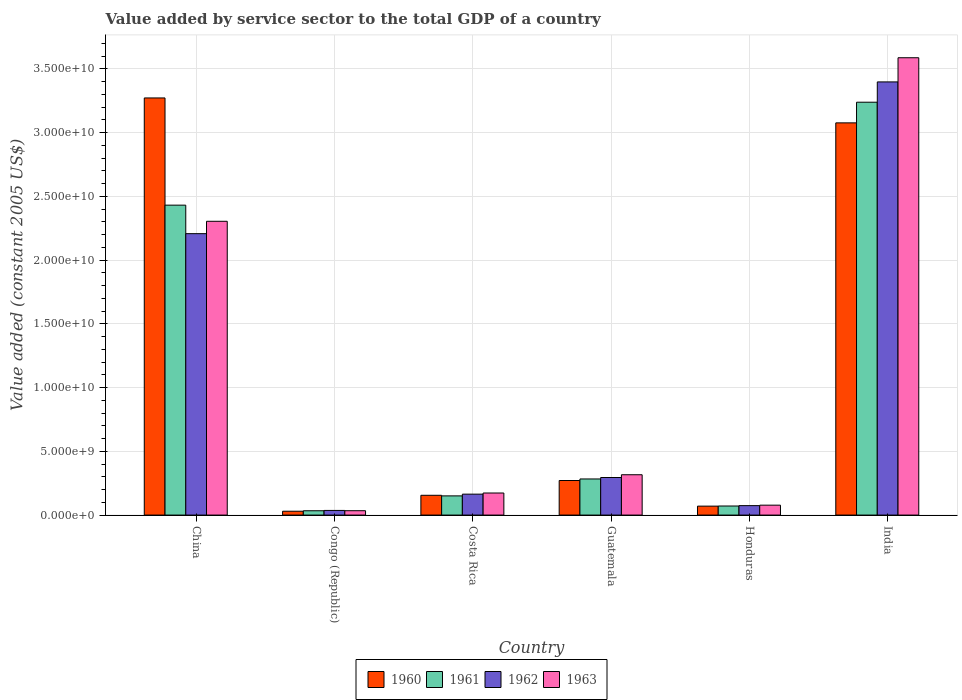How many different coloured bars are there?
Keep it short and to the point. 4. How many groups of bars are there?
Ensure brevity in your answer.  6. Are the number of bars per tick equal to the number of legend labels?
Offer a terse response. Yes. Are the number of bars on each tick of the X-axis equal?
Offer a terse response. Yes. How many bars are there on the 6th tick from the left?
Provide a short and direct response. 4. What is the label of the 5th group of bars from the left?
Give a very brief answer. Honduras. In how many cases, is the number of bars for a given country not equal to the number of legend labels?
Your response must be concise. 0. What is the value added by service sector in 1961 in China?
Your answer should be compact. 2.43e+1. Across all countries, what is the maximum value added by service sector in 1960?
Your response must be concise. 3.27e+1. Across all countries, what is the minimum value added by service sector in 1960?
Your answer should be compact. 3.02e+08. In which country was the value added by service sector in 1960 maximum?
Offer a terse response. China. In which country was the value added by service sector in 1963 minimum?
Provide a short and direct response. Congo (Republic). What is the total value added by service sector in 1963 in the graph?
Your response must be concise. 6.49e+1. What is the difference between the value added by service sector in 1962 in Congo (Republic) and that in Costa Rica?
Give a very brief answer. -1.28e+09. What is the difference between the value added by service sector in 1962 in China and the value added by service sector in 1961 in Honduras?
Provide a succinct answer. 2.14e+1. What is the average value added by service sector in 1960 per country?
Your answer should be compact. 1.15e+1. What is the difference between the value added by service sector of/in 1962 and value added by service sector of/in 1963 in Guatemala?
Make the answer very short. -2.17e+08. In how many countries, is the value added by service sector in 1960 greater than 8000000000 US$?
Ensure brevity in your answer.  2. What is the ratio of the value added by service sector in 1962 in Congo (Republic) to that in Honduras?
Your answer should be compact. 0.49. Is the value added by service sector in 1963 in Congo (Republic) less than that in India?
Provide a succinct answer. Yes. Is the difference between the value added by service sector in 1962 in Guatemala and India greater than the difference between the value added by service sector in 1963 in Guatemala and India?
Ensure brevity in your answer.  Yes. What is the difference between the highest and the second highest value added by service sector in 1962?
Keep it short and to the point. -1.91e+1. What is the difference between the highest and the lowest value added by service sector in 1963?
Provide a short and direct response. 3.55e+1. Is the sum of the value added by service sector in 1962 in Congo (Republic) and Guatemala greater than the maximum value added by service sector in 1960 across all countries?
Offer a terse response. No. Is it the case that in every country, the sum of the value added by service sector in 1962 and value added by service sector in 1960 is greater than the sum of value added by service sector in 1963 and value added by service sector in 1961?
Your answer should be compact. No. What does the 4th bar from the left in India represents?
Offer a terse response. 1963. What does the 3rd bar from the right in Congo (Republic) represents?
Make the answer very short. 1961. Are all the bars in the graph horizontal?
Keep it short and to the point. No. How many countries are there in the graph?
Ensure brevity in your answer.  6. Are the values on the major ticks of Y-axis written in scientific E-notation?
Your answer should be compact. Yes. Where does the legend appear in the graph?
Provide a short and direct response. Bottom center. How are the legend labels stacked?
Keep it short and to the point. Horizontal. What is the title of the graph?
Provide a short and direct response. Value added by service sector to the total GDP of a country. Does "1972" appear as one of the legend labels in the graph?
Your answer should be compact. No. What is the label or title of the X-axis?
Your answer should be very brief. Country. What is the label or title of the Y-axis?
Keep it short and to the point. Value added (constant 2005 US$). What is the Value added (constant 2005 US$) of 1960 in China?
Offer a very short reply. 3.27e+1. What is the Value added (constant 2005 US$) of 1961 in China?
Offer a very short reply. 2.43e+1. What is the Value added (constant 2005 US$) in 1962 in China?
Ensure brevity in your answer.  2.21e+1. What is the Value added (constant 2005 US$) in 1963 in China?
Provide a short and direct response. 2.30e+1. What is the Value added (constant 2005 US$) of 1960 in Congo (Republic)?
Provide a succinct answer. 3.02e+08. What is the Value added (constant 2005 US$) in 1961 in Congo (Republic)?
Keep it short and to the point. 3.39e+08. What is the Value added (constant 2005 US$) in 1962 in Congo (Republic)?
Offer a terse response. 3.64e+08. What is the Value added (constant 2005 US$) of 1963 in Congo (Republic)?
Ensure brevity in your answer.  3.42e+08. What is the Value added (constant 2005 US$) in 1960 in Costa Rica?
Provide a succinct answer. 1.55e+09. What is the Value added (constant 2005 US$) in 1961 in Costa Rica?
Give a very brief answer. 1.51e+09. What is the Value added (constant 2005 US$) in 1962 in Costa Rica?
Offer a very short reply. 1.64e+09. What is the Value added (constant 2005 US$) in 1963 in Costa Rica?
Provide a short and direct response. 1.73e+09. What is the Value added (constant 2005 US$) of 1960 in Guatemala?
Ensure brevity in your answer.  2.71e+09. What is the Value added (constant 2005 US$) of 1961 in Guatemala?
Your answer should be compact. 2.83e+09. What is the Value added (constant 2005 US$) of 1962 in Guatemala?
Make the answer very short. 2.95e+09. What is the Value added (constant 2005 US$) of 1963 in Guatemala?
Make the answer very short. 3.16e+09. What is the Value added (constant 2005 US$) of 1960 in Honduras?
Give a very brief answer. 7.01e+08. What is the Value added (constant 2005 US$) in 1961 in Honduras?
Your answer should be very brief. 7.12e+08. What is the Value added (constant 2005 US$) of 1962 in Honduras?
Make the answer very short. 7.41e+08. What is the Value added (constant 2005 US$) in 1963 in Honduras?
Your response must be concise. 7.78e+08. What is the Value added (constant 2005 US$) of 1960 in India?
Offer a terse response. 3.08e+1. What is the Value added (constant 2005 US$) in 1961 in India?
Your answer should be compact. 3.24e+1. What is the Value added (constant 2005 US$) in 1962 in India?
Give a very brief answer. 3.40e+1. What is the Value added (constant 2005 US$) of 1963 in India?
Your answer should be very brief. 3.59e+1. Across all countries, what is the maximum Value added (constant 2005 US$) in 1960?
Your answer should be very brief. 3.27e+1. Across all countries, what is the maximum Value added (constant 2005 US$) of 1961?
Make the answer very short. 3.24e+1. Across all countries, what is the maximum Value added (constant 2005 US$) in 1962?
Your answer should be very brief. 3.40e+1. Across all countries, what is the maximum Value added (constant 2005 US$) in 1963?
Your response must be concise. 3.59e+1. Across all countries, what is the minimum Value added (constant 2005 US$) in 1960?
Ensure brevity in your answer.  3.02e+08. Across all countries, what is the minimum Value added (constant 2005 US$) in 1961?
Offer a terse response. 3.39e+08. Across all countries, what is the minimum Value added (constant 2005 US$) of 1962?
Offer a terse response. 3.64e+08. Across all countries, what is the minimum Value added (constant 2005 US$) of 1963?
Ensure brevity in your answer.  3.42e+08. What is the total Value added (constant 2005 US$) of 1960 in the graph?
Give a very brief answer. 6.88e+1. What is the total Value added (constant 2005 US$) of 1961 in the graph?
Your response must be concise. 6.21e+1. What is the total Value added (constant 2005 US$) of 1962 in the graph?
Your response must be concise. 6.18e+1. What is the total Value added (constant 2005 US$) in 1963 in the graph?
Your answer should be very brief. 6.49e+1. What is the difference between the Value added (constant 2005 US$) in 1960 in China and that in Congo (Republic)?
Keep it short and to the point. 3.24e+1. What is the difference between the Value added (constant 2005 US$) in 1961 in China and that in Congo (Republic)?
Your response must be concise. 2.40e+1. What is the difference between the Value added (constant 2005 US$) of 1962 in China and that in Congo (Republic)?
Give a very brief answer. 2.17e+1. What is the difference between the Value added (constant 2005 US$) in 1963 in China and that in Congo (Republic)?
Keep it short and to the point. 2.27e+1. What is the difference between the Value added (constant 2005 US$) of 1960 in China and that in Costa Rica?
Ensure brevity in your answer.  3.12e+1. What is the difference between the Value added (constant 2005 US$) of 1961 in China and that in Costa Rica?
Your response must be concise. 2.28e+1. What is the difference between the Value added (constant 2005 US$) in 1962 in China and that in Costa Rica?
Provide a succinct answer. 2.04e+1. What is the difference between the Value added (constant 2005 US$) of 1963 in China and that in Costa Rica?
Give a very brief answer. 2.13e+1. What is the difference between the Value added (constant 2005 US$) of 1960 in China and that in Guatemala?
Your response must be concise. 3.00e+1. What is the difference between the Value added (constant 2005 US$) of 1961 in China and that in Guatemala?
Your answer should be very brief. 2.15e+1. What is the difference between the Value added (constant 2005 US$) in 1962 in China and that in Guatemala?
Provide a short and direct response. 1.91e+1. What is the difference between the Value added (constant 2005 US$) in 1963 in China and that in Guatemala?
Keep it short and to the point. 1.99e+1. What is the difference between the Value added (constant 2005 US$) in 1960 in China and that in Honduras?
Offer a terse response. 3.20e+1. What is the difference between the Value added (constant 2005 US$) of 1961 in China and that in Honduras?
Provide a succinct answer. 2.36e+1. What is the difference between the Value added (constant 2005 US$) of 1962 in China and that in Honduras?
Keep it short and to the point. 2.13e+1. What is the difference between the Value added (constant 2005 US$) of 1963 in China and that in Honduras?
Your response must be concise. 2.23e+1. What is the difference between the Value added (constant 2005 US$) in 1960 in China and that in India?
Offer a very short reply. 1.95e+09. What is the difference between the Value added (constant 2005 US$) of 1961 in China and that in India?
Offer a terse response. -8.08e+09. What is the difference between the Value added (constant 2005 US$) of 1962 in China and that in India?
Provide a short and direct response. -1.19e+1. What is the difference between the Value added (constant 2005 US$) of 1963 in China and that in India?
Keep it short and to the point. -1.28e+1. What is the difference between the Value added (constant 2005 US$) in 1960 in Congo (Republic) and that in Costa Rica?
Offer a terse response. -1.25e+09. What is the difference between the Value added (constant 2005 US$) in 1961 in Congo (Republic) and that in Costa Rica?
Ensure brevity in your answer.  -1.17e+09. What is the difference between the Value added (constant 2005 US$) in 1962 in Congo (Republic) and that in Costa Rica?
Your answer should be compact. -1.28e+09. What is the difference between the Value added (constant 2005 US$) in 1963 in Congo (Republic) and that in Costa Rica?
Your response must be concise. -1.39e+09. What is the difference between the Value added (constant 2005 US$) of 1960 in Congo (Republic) and that in Guatemala?
Offer a terse response. -2.41e+09. What is the difference between the Value added (constant 2005 US$) of 1961 in Congo (Republic) and that in Guatemala?
Keep it short and to the point. -2.49e+09. What is the difference between the Value added (constant 2005 US$) in 1962 in Congo (Republic) and that in Guatemala?
Provide a short and direct response. -2.58e+09. What is the difference between the Value added (constant 2005 US$) of 1963 in Congo (Republic) and that in Guatemala?
Provide a short and direct response. -2.82e+09. What is the difference between the Value added (constant 2005 US$) in 1960 in Congo (Republic) and that in Honduras?
Offer a terse response. -4.00e+08. What is the difference between the Value added (constant 2005 US$) of 1961 in Congo (Republic) and that in Honduras?
Keep it short and to the point. -3.73e+08. What is the difference between the Value added (constant 2005 US$) of 1962 in Congo (Republic) and that in Honduras?
Provide a short and direct response. -3.77e+08. What is the difference between the Value added (constant 2005 US$) of 1963 in Congo (Republic) and that in Honduras?
Make the answer very short. -4.36e+08. What is the difference between the Value added (constant 2005 US$) of 1960 in Congo (Republic) and that in India?
Provide a succinct answer. -3.05e+1. What is the difference between the Value added (constant 2005 US$) of 1961 in Congo (Republic) and that in India?
Give a very brief answer. -3.21e+1. What is the difference between the Value added (constant 2005 US$) of 1962 in Congo (Republic) and that in India?
Offer a very short reply. -3.36e+1. What is the difference between the Value added (constant 2005 US$) in 1963 in Congo (Republic) and that in India?
Offer a terse response. -3.55e+1. What is the difference between the Value added (constant 2005 US$) in 1960 in Costa Rica and that in Guatemala?
Give a very brief answer. -1.16e+09. What is the difference between the Value added (constant 2005 US$) of 1961 in Costa Rica and that in Guatemala?
Ensure brevity in your answer.  -1.33e+09. What is the difference between the Value added (constant 2005 US$) in 1962 in Costa Rica and that in Guatemala?
Offer a terse response. -1.31e+09. What is the difference between the Value added (constant 2005 US$) in 1963 in Costa Rica and that in Guatemala?
Offer a terse response. -1.43e+09. What is the difference between the Value added (constant 2005 US$) of 1960 in Costa Rica and that in Honduras?
Offer a terse response. 8.51e+08. What is the difference between the Value added (constant 2005 US$) of 1961 in Costa Rica and that in Honduras?
Provide a short and direct response. 7.94e+08. What is the difference between the Value added (constant 2005 US$) in 1962 in Costa Rica and that in Honduras?
Offer a very short reply. 9.01e+08. What is the difference between the Value added (constant 2005 US$) of 1963 in Costa Rica and that in Honduras?
Your response must be concise. 9.53e+08. What is the difference between the Value added (constant 2005 US$) of 1960 in Costa Rica and that in India?
Your answer should be very brief. -2.92e+1. What is the difference between the Value added (constant 2005 US$) in 1961 in Costa Rica and that in India?
Provide a short and direct response. -3.09e+1. What is the difference between the Value added (constant 2005 US$) of 1962 in Costa Rica and that in India?
Provide a succinct answer. -3.23e+1. What is the difference between the Value added (constant 2005 US$) in 1963 in Costa Rica and that in India?
Make the answer very short. -3.41e+1. What is the difference between the Value added (constant 2005 US$) in 1960 in Guatemala and that in Honduras?
Provide a short and direct response. 2.01e+09. What is the difference between the Value added (constant 2005 US$) in 1961 in Guatemala and that in Honduras?
Offer a terse response. 2.12e+09. What is the difference between the Value added (constant 2005 US$) of 1962 in Guatemala and that in Honduras?
Ensure brevity in your answer.  2.21e+09. What is the difference between the Value added (constant 2005 US$) in 1963 in Guatemala and that in Honduras?
Ensure brevity in your answer.  2.39e+09. What is the difference between the Value added (constant 2005 US$) of 1960 in Guatemala and that in India?
Your answer should be very brief. -2.81e+1. What is the difference between the Value added (constant 2005 US$) of 1961 in Guatemala and that in India?
Offer a very short reply. -2.96e+1. What is the difference between the Value added (constant 2005 US$) in 1962 in Guatemala and that in India?
Offer a very short reply. -3.10e+1. What is the difference between the Value added (constant 2005 US$) in 1963 in Guatemala and that in India?
Give a very brief answer. -3.27e+1. What is the difference between the Value added (constant 2005 US$) of 1960 in Honduras and that in India?
Your response must be concise. -3.01e+1. What is the difference between the Value added (constant 2005 US$) of 1961 in Honduras and that in India?
Your response must be concise. -3.17e+1. What is the difference between the Value added (constant 2005 US$) in 1962 in Honduras and that in India?
Your answer should be very brief. -3.32e+1. What is the difference between the Value added (constant 2005 US$) of 1963 in Honduras and that in India?
Your answer should be very brief. -3.51e+1. What is the difference between the Value added (constant 2005 US$) of 1960 in China and the Value added (constant 2005 US$) of 1961 in Congo (Republic)?
Offer a very short reply. 3.24e+1. What is the difference between the Value added (constant 2005 US$) of 1960 in China and the Value added (constant 2005 US$) of 1962 in Congo (Republic)?
Give a very brief answer. 3.24e+1. What is the difference between the Value added (constant 2005 US$) in 1960 in China and the Value added (constant 2005 US$) in 1963 in Congo (Republic)?
Offer a terse response. 3.24e+1. What is the difference between the Value added (constant 2005 US$) in 1961 in China and the Value added (constant 2005 US$) in 1962 in Congo (Republic)?
Provide a succinct answer. 2.39e+1. What is the difference between the Value added (constant 2005 US$) in 1961 in China and the Value added (constant 2005 US$) in 1963 in Congo (Republic)?
Offer a terse response. 2.40e+1. What is the difference between the Value added (constant 2005 US$) of 1962 in China and the Value added (constant 2005 US$) of 1963 in Congo (Republic)?
Provide a short and direct response. 2.17e+1. What is the difference between the Value added (constant 2005 US$) in 1960 in China and the Value added (constant 2005 US$) in 1961 in Costa Rica?
Provide a succinct answer. 3.12e+1. What is the difference between the Value added (constant 2005 US$) in 1960 in China and the Value added (constant 2005 US$) in 1962 in Costa Rica?
Keep it short and to the point. 3.11e+1. What is the difference between the Value added (constant 2005 US$) in 1960 in China and the Value added (constant 2005 US$) in 1963 in Costa Rica?
Your answer should be very brief. 3.10e+1. What is the difference between the Value added (constant 2005 US$) of 1961 in China and the Value added (constant 2005 US$) of 1962 in Costa Rica?
Keep it short and to the point. 2.27e+1. What is the difference between the Value added (constant 2005 US$) of 1961 in China and the Value added (constant 2005 US$) of 1963 in Costa Rica?
Your response must be concise. 2.26e+1. What is the difference between the Value added (constant 2005 US$) in 1962 in China and the Value added (constant 2005 US$) in 1963 in Costa Rica?
Give a very brief answer. 2.03e+1. What is the difference between the Value added (constant 2005 US$) of 1960 in China and the Value added (constant 2005 US$) of 1961 in Guatemala?
Provide a short and direct response. 2.99e+1. What is the difference between the Value added (constant 2005 US$) of 1960 in China and the Value added (constant 2005 US$) of 1962 in Guatemala?
Your answer should be very brief. 2.98e+1. What is the difference between the Value added (constant 2005 US$) in 1960 in China and the Value added (constant 2005 US$) in 1963 in Guatemala?
Provide a succinct answer. 2.96e+1. What is the difference between the Value added (constant 2005 US$) of 1961 in China and the Value added (constant 2005 US$) of 1962 in Guatemala?
Ensure brevity in your answer.  2.14e+1. What is the difference between the Value added (constant 2005 US$) of 1961 in China and the Value added (constant 2005 US$) of 1963 in Guatemala?
Give a very brief answer. 2.11e+1. What is the difference between the Value added (constant 2005 US$) in 1962 in China and the Value added (constant 2005 US$) in 1963 in Guatemala?
Make the answer very short. 1.89e+1. What is the difference between the Value added (constant 2005 US$) in 1960 in China and the Value added (constant 2005 US$) in 1961 in Honduras?
Offer a terse response. 3.20e+1. What is the difference between the Value added (constant 2005 US$) of 1960 in China and the Value added (constant 2005 US$) of 1962 in Honduras?
Your response must be concise. 3.20e+1. What is the difference between the Value added (constant 2005 US$) of 1960 in China and the Value added (constant 2005 US$) of 1963 in Honduras?
Make the answer very short. 3.19e+1. What is the difference between the Value added (constant 2005 US$) in 1961 in China and the Value added (constant 2005 US$) in 1962 in Honduras?
Offer a very short reply. 2.36e+1. What is the difference between the Value added (constant 2005 US$) in 1961 in China and the Value added (constant 2005 US$) in 1963 in Honduras?
Offer a terse response. 2.35e+1. What is the difference between the Value added (constant 2005 US$) in 1962 in China and the Value added (constant 2005 US$) in 1963 in Honduras?
Make the answer very short. 2.13e+1. What is the difference between the Value added (constant 2005 US$) in 1960 in China and the Value added (constant 2005 US$) in 1961 in India?
Offer a terse response. 3.34e+08. What is the difference between the Value added (constant 2005 US$) of 1960 in China and the Value added (constant 2005 US$) of 1962 in India?
Ensure brevity in your answer.  -1.26e+09. What is the difference between the Value added (constant 2005 US$) in 1960 in China and the Value added (constant 2005 US$) in 1963 in India?
Offer a very short reply. -3.15e+09. What is the difference between the Value added (constant 2005 US$) in 1961 in China and the Value added (constant 2005 US$) in 1962 in India?
Your answer should be compact. -9.67e+09. What is the difference between the Value added (constant 2005 US$) in 1961 in China and the Value added (constant 2005 US$) in 1963 in India?
Keep it short and to the point. -1.16e+1. What is the difference between the Value added (constant 2005 US$) of 1962 in China and the Value added (constant 2005 US$) of 1963 in India?
Provide a short and direct response. -1.38e+1. What is the difference between the Value added (constant 2005 US$) in 1960 in Congo (Republic) and the Value added (constant 2005 US$) in 1961 in Costa Rica?
Provide a succinct answer. -1.20e+09. What is the difference between the Value added (constant 2005 US$) of 1960 in Congo (Republic) and the Value added (constant 2005 US$) of 1962 in Costa Rica?
Offer a very short reply. -1.34e+09. What is the difference between the Value added (constant 2005 US$) in 1960 in Congo (Republic) and the Value added (constant 2005 US$) in 1963 in Costa Rica?
Make the answer very short. -1.43e+09. What is the difference between the Value added (constant 2005 US$) of 1961 in Congo (Republic) and the Value added (constant 2005 US$) of 1962 in Costa Rica?
Provide a succinct answer. -1.30e+09. What is the difference between the Value added (constant 2005 US$) in 1961 in Congo (Republic) and the Value added (constant 2005 US$) in 1963 in Costa Rica?
Offer a terse response. -1.39e+09. What is the difference between the Value added (constant 2005 US$) in 1962 in Congo (Republic) and the Value added (constant 2005 US$) in 1963 in Costa Rica?
Your answer should be compact. -1.37e+09. What is the difference between the Value added (constant 2005 US$) in 1960 in Congo (Republic) and the Value added (constant 2005 US$) in 1961 in Guatemala?
Your answer should be compact. -2.53e+09. What is the difference between the Value added (constant 2005 US$) in 1960 in Congo (Republic) and the Value added (constant 2005 US$) in 1962 in Guatemala?
Give a very brief answer. -2.65e+09. What is the difference between the Value added (constant 2005 US$) in 1960 in Congo (Republic) and the Value added (constant 2005 US$) in 1963 in Guatemala?
Provide a short and direct response. -2.86e+09. What is the difference between the Value added (constant 2005 US$) in 1961 in Congo (Republic) and the Value added (constant 2005 US$) in 1962 in Guatemala?
Ensure brevity in your answer.  -2.61e+09. What is the difference between the Value added (constant 2005 US$) of 1961 in Congo (Republic) and the Value added (constant 2005 US$) of 1963 in Guatemala?
Provide a short and direct response. -2.83e+09. What is the difference between the Value added (constant 2005 US$) of 1962 in Congo (Republic) and the Value added (constant 2005 US$) of 1963 in Guatemala?
Your answer should be very brief. -2.80e+09. What is the difference between the Value added (constant 2005 US$) in 1960 in Congo (Republic) and the Value added (constant 2005 US$) in 1961 in Honduras?
Offer a terse response. -4.10e+08. What is the difference between the Value added (constant 2005 US$) of 1960 in Congo (Republic) and the Value added (constant 2005 US$) of 1962 in Honduras?
Your response must be concise. -4.39e+08. What is the difference between the Value added (constant 2005 US$) of 1960 in Congo (Republic) and the Value added (constant 2005 US$) of 1963 in Honduras?
Provide a succinct answer. -4.76e+08. What is the difference between the Value added (constant 2005 US$) in 1961 in Congo (Republic) and the Value added (constant 2005 US$) in 1962 in Honduras?
Provide a succinct answer. -4.02e+08. What is the difference between the Value added (constant 2005 US$) of 1961 in Congo (Republic) and the Value added (constant 2005 US$) of 1963 in Honduras?
Offer a very short reply. -4.39e+08. What is the difference between the Value added (constant 2005 US$) of 1962 in Congo (Republic) and the Value added (constant 2005 US$) of 1963 in Honduras?
Give a very brief answer. -4.14e+08. What is the difference between the Value added (constant 2005 US$) of 1960 in Congo (Republic) and the Value added (constant 2005 US$) of 1961 in India?
Your answer should be very brief. -3.21e+1. What is the difference between the Value added (constant 2005 US$) in 1960 in Congo (Republic) and the Value added (constant 2005 US$) in 1962 in India?
Give a very brief answer. -3.37e+1. What is the difference between the Value added (constant 2005 US$) of 1960 in Congo (Republic) and the Value added (constant 2005 US$) of 1963 in India?
Offer a terse response. -3.56e+1. What is the difference between the Value added (constant 2005 US$) in 1961 in Congo (Republic) and the Value added (constant 2005 US$) in 1962 in India?
Provide a short and direct response. -3.36e+1. What is the difference between the Value added (constant 2005 US$) in 1961 in Congo (Republic) and the Value added (constant 2005 US$) in 1963 in India?
Give a very brief answer. -3.55e+1. What is the difference between the Value added (constant 2005 US$) in 1962 in Congo (Republic) and the Value added (constant 2005 US$) in 1963 in India?
Provide a short and direct response. -3.55e+1. What is the difference between the Value added (constant 2005 US$) of 1960 in Costa Rica and the Value added (constant 2005 US$) of 1961 in Guatemala?
Your answer should be compact. -1.28e+09. What is the difference between the Value added (constant 2005 US$) of 1960 in Costa Rica and the Value added (constant 2005 US$) of 1962 in Guatemala?
Offer a terse response. -1.39e+09. What is the difference between the Value added (constant 2005 US$) of 1960 in Costa Rica and the Value added (constant 2005 US$) of 1963 in Guatemala?
Ensure brevity in your answer.  -1.61e+09. What is the difference between the Value added (constant 2005 US$) in 1961 in Costa Rica and the Value added (constant 2005 US$) in 1962 in Guatemala?
Your answer should be very brief. -1.44e+09. What is the difference between the Value added (constant 2005 US$) in 1961 in Costa Rica and the Value added (constant 2005 US$) in 1963 in Guatemala?
Offer a very short reply. -1.66e+09. What is the difference between the Value added (constant 2005 US$) of 1962 in Costa Rica and the Value added (constant 2005 US$) of 1963 in Guatemala?
Ensure brevity in your answer.  -1.52e+09. What is the difference between the Value added (constant 2005 US$) in 1960 in Costa Rica and the Value added (constant 2005 US$) in 1961 in Honduras?
Offer a very short reply. 8.41e+08. What is the difference between the Value added (constant 2005 US$) of 1960 in Costa Rica and the Value added (constant 2005 US$) of 1962 in Honduras?
Make the answer very short. 8.12e+08. What is the difference between the Value added (constant 2005 US$) in 1960 in Costa Rica and the Value added (constant 2005 US$) in 1963 in Honduras?
Your response must be concise. 7.75e+08. What is the difference between the Value added (constant 2005 US$) in 1961 in Costa Rica and the Value added (constant 2005 US$) in 1962 in Honduras?
Offer a very short reply. 7.65e+08. What is the difference between the Value added (constant 2005 US$) of 1961 in Costa Rica and the Value added (constant 2005 US$) of 1963 in Honduras?
Give a very brief answer. 7.28e+08. What is the difference between the Value added (constant 2005 US$) of 1962 in Costa Rica and the Value added (constant 2005 US$) of 1963 in Honduras?
Your response must be concise. 8.63e+08. What is the difference between the Value added (constant 2005 US$) in 1960 in Costa Rica and the Value added (constant 2005 US$) in 1961 in India?
Provide a short and direct response. -3.08e+1. What is the difference between the Value added (constant 2005 US$) of 1960 in Costa Rica and the Value added (constant 2005 US$) of 1962 in India?
Offer a very short reply. -3.24e+1. What is the difference between the Value added (constant 2005 US$) in 1960 in Costa Rica and the Value added (constant 2005 US$) in 1963 in India?
Ensure brevity in your answer.  -3.43e+1. What is the difference between the Value added (constant 2005 US$) in 1961 in Costa Rica and the Value added (constant 2005 US$) in 1962 in India?
Your answer should be compact. -3.25e+1. What is the difference between the Value added (constant 2005 US$) in 1961 in Costa Rica and the Value added (constant 2005 US$) in 1963 in India?
Your answer should be very brief. -3.44e+1. What is the difference between the Value added (constant 2005 US$) in 1962 in Costa Rica and the Value added (constant 2005 US$) in 1963 in India?
Your answer should be very brief. -3.42e+1. What is the difference between the Value added (constant 2005 US$) in 1960 in Guatemala and the Value added (constant 2005 US$) in 1961 in Honduras?
Your response must be concise. 2.00e+09. What is the difference between the Value added (constant 2005 US$) in 1960 in Guatemala and the Value added (constant 2005 US$) in 1962 in Honduras?
Give a very brief answer. 1.97e+09. What is the difference between the Value added (constant 2005 US$) in 1960 in Guatemala and the Value added (constant 2005 US$) in 1963 in Honduras?
Provide a succinct answer. 1.93e+09. What is the difference between the Value added (constant 2005 US$) in 1961 in Guatemala and the Value added (constant 2005 US$) in 1962 in Honduras?
Offer a very short reply. 2.09e+09. What is the difference between the Value added (constant 2005 US$) in 1961 in Guatemala and the Value added (constant 2005 US$) in 1963 in Honduras?
Make the answer very short. 2.06e+09. What is the difference between the Value added (constant 2005 US$) of 1962 in Guatemala and the Value added (constant 2005 US$) of 1963 in Honduras?
Ensure brevity in your answer.  2.17e+09. What is the difference between the Value added (constant 2005 US$) of 1960 in Guatemala and the Value added (constant 2005 US$) of 1961 in India?
Your response must be concise. -2.97e+1. What is the difference between the Value added (constant 2005 US$) of 1960 in Guatemala and the Value added (constant 2005 US$) of 1962 in India?
Offer a very short reply. -3.13e+1. What is the difference between the Value added (constant 2005 US$) in 1960 in Guatemala and the Value added (constant 2005 US$) in 1963 in India?
Offer a terse response. -3.32e+1. What is the difference between the Value added (constant 2005 US$) of 1961 in Guatemala and the Value added (constant 2005 US$) of 1962 in India?
Your response must be concise. -3.11e+1. What is the difference between the Value added (constant 2005 US$) of 1961 in Guatemala and the Value added (constant 2005 US$) of 1963 in India?
Your answer should be compact. -3.30e+1. What is the difference between the Value added (constant 2005 US$) in 1962 in Guatemala and the Value added (constant 2005 US$) in 1963 in India?
Ensure brevity in your answer.  -3.29e+1. What is the difference between the Value added (constant 2005 US$) in 1960 in Honduras and the Value added (constant 2005 US$) in 1961 in India?
Your response must be concise. -3.17e+1. What is the difference between the Value added (constant 2005 US$) of 1960 in Honduras and the Value added (constant 2005 US$) of 1962 in India?
Your answer should be very brief. -3.33e+1. What is the difference between the Value added (constant 2005 US$) in 1960 in Honduras and the Value added (constant 2005 US$) in 1963 in India?
Provide a short and direct response. -3.52e+1. What is the difference between the Value added (constant 2005 US$) in 1961 in Honduras and the Value added (constant 2005 US$) in 1962 in India?
Give a very brief answer. -3.33e+1. What is the difference between the Value added (constant 2005 US$) in 1961 in Honduras and the Value added (constant 2005 US$) in 1963 in India?
Your answer should be compact. -3.52e+1. What is the difference between the Value added (constant 2005 US$) in 1962 in Honduras and the Value added (constant 2005 US$) in 1963 in India?
Give a very brief answer. -3.51e+1. What is the average Value added (constant 2005 US$) in 1960 per country?
Offer a terse response. 1.15e+1. What is the average Value added (constant 2005 US$) in 1961 per country?
Keep it short and to the point. 1.03e+1. What is the average Value added (constant 2005 US$) in 1962 per country?
Your response must be concise. 1.03e+1. What is the average Value added (constant 2005 US$) in 1963 per country?
Offer a very short reply. 1.08e+1. What is the difference between the Value added (constant 2005 US$) in 1960 and Value added (constant 2005 US$) in 1961 in China?
Your response must be concise. 8.41e+09. What is the difference between the Value added (constant 2005 US$) in 1960 and Value added (constant 2005 US$) in 1962 in China?
Give a very brief answer. 1.06e+1. What is the difference between the Value added (constant 2005 US$) in 1960 and Value added (constant 2005 US$) in 1963 in China?
Offer a very short reply. 9.68e+09. What is the difference between the Value added (constant 2005 US$) of 1961 and Value added (constant 2005 US$) of 1962 in China?
Offer a very short reply. 2.24e+09. What is the difference between the Value added (constant 2005 US$) in 1961 and Value added (constant 2005 US$) in 1963 in China?
Offer a terse response. 1.27e+09. What is the difference between the Value added (constant 2005 US$) in 1962 and Value added (constant 2005 US$) in 1963 in China?
Keep it short and to the point. -9.71e+08. What is the difference between the Value added (constant 2005 US$) of 1960 and Value added (constant 2005 US$) of 1961 in Congo (Republic)?
Make the answer very short. -3.74e+07. What is the difference between the Value added (constant 2005 US$) of 1960 and Value added (constant 2005 US$) of 1962 in Congo (Republic)?
Give a very brief answer. -6.23e+07. What is the difference between the Value added (constant 2005 US$) of 1960 and Value added (constant 2005 US$) of 1963 in Congo (Republic)?
Offer a terse response. -4.05e+07. What is the difference between the Value added (constant 2005 US$) in 1961 and Value added (constant 2005 US$) in 1962 in Congo (Republic)?
Your answer should be very brief. -2.49e+07. What is the difference between the Value added (constant 2005 US$) in 1961 and Value added (constant 2005 US$) in 1963 in Congo (Republic)?
Provide a short and direct response. -3.09e+06. What is the difference between the Value added (constant 2005 US$) in 1962 and Value added (constant 2005 US$) in 1963 in Congo (Republic)?
Keep it short and to the point. 2.18e+07. What is the difference between the Value added (constant 2005 US$) in 1960 and Value added (constant 2005 US$) in 1961 in Costa Rica?
Give a very brief answer. 4.72e+07. What is the difference between the Value added (constant 2005 US$) in 1960 and Value added (constant 2005 US$) in 1962 in Costa Rica?
Provide a succinct answer. -8.87e+07. What is the difference between the Value added (constant 2005 US$) of 1960 and Value added (constant 2005 US$) of 1963 in Costa Rica?
Offer a very short reply. -1.78e+08. What is the difference between the Value added (constant 2005 US$) in 1961 and Value added (constant 2005 US$) in 1962 in Costa Rica?
Keep it short and to the point. -1.36e+08. What is the difference between the Value added (constant 2005 US$) of 1961 and Value added (constant 2005 US$) of 1963 in Costa Rica?
Your response must be concise. -2.25e+08. What is the difference between the Value added (constant 2005 US$) of 1962 and Value added (constant 2005 US$) of 1963 in Costa Rica?
Offer a terse response. -8.94e+07. What is the difference between the Value added (constant 2005 US$) in 1960 and Value added (constant 2005 US$) in 1961 in Guatemala?
Your response must be concise. -1.22e+08. What is the difference between the Value added (constant 2005 US$) of 1960 and Value added (constant 2005 US$) of 1962 in Guatemala?
Your answer should be very brief. -2.35e+08. What is the difference between the Value added (constant 2005 US$) of 1960 and Value added (constant 2005 US$) of 1963 in Guatemala?
Your answer should be very brief. -4.53e+08. What is the difference between the Value added (constant 2005 US$) in 1961 and Value added (constant 2005 US$) in 1962 in Guatemala?
Your response must be concise. -1.14e+08. What is the difference between the Value added (constant 2005 US$) in 1961 and Value added (constant 2005 US$) in 1963 in Guatemala?
Keep it short and to the point. -3.31e+08. What is the difference between the Value added (constant 2005 US$) in 1962 and Value added (constant 2005 US$) in 1963 in Guatemala?
Give a very brief answer. -2.17e+08. What is the difference between the Value added (constant 2005 US$) of 1960 and Value added (constant 2005 US$) of 1961 in Honduras?
Keep it short and to the point. -1.04e+07. What is the difference between the Value added (constant 2005 US$) in 1960 and Value added (constant 2005 US$) in 1962 in Honduras?
Keep it short and to the point. -3.93e+07. What is the difference between the Value added (constant 2005 US$) in 1960 and Value added (constant 2005 US$) in 1963 in Honduras?
Your response must be concise. -7.65e+07. What is the difference between the Value added (constant 2005 US$) in 1961 and Value added (constant 2005 US$) in 1962 in Honduras?
Make the answer very short. -2.89e+07. What is the difference between the Value added (constant 2005 US$) of 1961 and Value added (constant 2005 US$) of 1963 in Honduras?
Offer a terse response. -6.62e+07. What is the difference between the Value added (constant 2005 US$) of 1962 and Value added (constant 2005 US$) of 1963 in Honduras?
Offer a terse response. -3.72e+07. What is the difference between the Value added (constant 2005 US$) in 1960 and Value added (constant 2005 US$) in 1961 in India?
Provide a short and direct response. -1.62e+09. What is the difference between the Value added (constant 2005 US$) in 1960 and Value added (constant 2005 US$) in 1962 in India?
Make the answer very short. -3.21e+09. What is the difference between the Value added (constant 2005 US$) in 1960 and Value added (constant 2005 US$) in 1963 in India?
Provide a succinct answer. -5.11e+09. What is the difference between the Value added (constant 2005 US$) in 1961 and Value added (constant 2005 US$) in 1962 in India?
Your response must be concise. -1.59e+09. What is the difference between the Value added (constant 2005 US$) in 1961 and Value added (constant 2005 US$) in 1963 in India?
Keep it short and to the point. -3.49e+09. What is the difference between the Value added (constant 2005 US$) in 1962 and Value added (constant 2005 US$) in 1963 in India?
Ensure brevity in your answer.  -1.90e+09. What is the ratio of the Value added (constant 2005 US$) of 1960 in China to that in Congo (Republic)?
Keep it short and to the point. 108.51. What is the ratio of the Value added (constant 2005 US$) of 1961 in China to that in Congo (Republic)?
Offer a very short reply. 71.73. What is the ratio of the Value added (constant 2005 US$) of 1962 in China to that in Congo (Republic)?
Your response must be concise. 60.67. What is the ratio of the Value added (constant 2005 US$) in 1963 in China to that in Congo (Republic)?
Offer a very short reply. 67.39. What is the ratio of the Value added (constant 2005 US$) in 1960 in China to that in Costa Rica?
Offer a terse response. 21.08. What is the ratio of the Value added (constant 2005 US$) of 1961 in China to that in Costa Rica?
Offer a very short reply. 16.15. What is the ratio of the Value added (constant 2005 US$) in 1962 in China to that in Costa Rica?
Your answer should be compact. 13.45. What is the ratio of the Value added (constant 2005 US$) in 1963 in China to that in Costa Rica?
Your answer should be very brief. 13.32. What is the ratio of the Value added (constant 2005 US$) of 1960 in China to that in Guatemala?
Your answer should be very brief. 12.07. What is the ratio of the Value added (constant 2005 US$) of 1961 in China to that in Guatemala?
Offer a terse response. 8.58. What is the ratio of the Value added (constant 2005 US$) in 1962 in China to that in Guatemala?
Provide a short and direct response. 7.49. What is the ratio of the Value added (constant 2005 US$) of 1963 in China to that in Guatemala?
Give a very brief answer. 7.28. What is the ratio of the Value added (constant 2005 US$) in 1960 in China to that in Honduras?
Ensure brevity in your answer.  46.67. What is the ratio of the Value added (constant 2005 US$) of 1961 in China to that in Honduras?
Offer a very short reply. 34.17. What is the ratio of the Value added (constant 2005 US$) of 1962 in China to that in Honduras?
Provide a succinct answer. 29.81. What is the ratio of the Value added (constant 2005 US$) of 1963 in China to that in Honduras?
Keep it short and to the point. 29.63. What is the ratio of the Value added (constant 2005 US$) of 1960 in China to that in India?
Provide a succinct answer. 1.06. What is the ratio of the Value added (constant 2005 US$) of 1961 in China to that in India?
Your response must be concise. 0.75. What is the ratio of the Value added (constant 2005 US$) of 1962 in China to that in India?
Your answer should be compact. 0.65. What is the ratio of the Value added (constant 2005 US$) of 1963 in China to that in India?
Keep it short and to the point. 0.64. What is the ratio of the Value added (constant 2005 US$) in 1960 in Congo (Republic) to that in Costa Rica?
Your answer should be compact. 0.19. What is the ratio of the Value added (constant 2005 US$) of 1961 in Congo (Republic) to that in Costa Rica?
Your answer should be very brief. 0.23. What is the ratio of the Value added (constant 2005 US$) in 1962 in Congo (Republic) to that in Costa Rica?
Make the answer very short. 0.22. What is the ratio of the Value added (constant 2005 US$) in 1963 in Congo (Republic) to that in Costa Rica?
Make the answer very short. 0.2. What is the ratio of the Value added (constant 2005 US$) in 1960 in Congo (Republic) to that in Guatemala?
Keep it short and to the point. 0.11. What is the ratio of the Value added (constant 2005 US$) of 1961 in Congo (Republic) to that in Guatemala?
Make the answer very short. 0.12. What is the ratio of the Value added (constant 2005 US$) in 1962 in Congo (Republic) to that in Guatemala?
Offer a very short reply. 0.12. What is the ratio of the Value added (constant 2005 US$) of 1963 in Congo (Republic) to that in Guatemala?
Offer a terse response. 0.11. What is the ratio of the Value added (constant 2005 US$) of 1960 in Congo (Republic) to that in Honduras?
Offer a very short reply. 0.43. What is the ratio of the Value added (constant 2005 US$) of 1961 in Congo (Republic) to that in Honduras?
Keep it short and to the point. 0.48. What is the ratio of the Value added (constant 2005 US$) of 1962 in Congo (Republic) to that in Honduras?
Ensure brevity in your answer.  0.49. What is the ratio of the Value added (constant 2005 US$) in 1963 in Congo (Republic) to that in Honduras?
Provide a short and direct response. 0.44. What is the ratio of the Value added (constant 2005 US$) of 1960 in Congo (Republic) to that in India?
Provide a succinct answer. 0.01. What is the ratio of the Value added (constant 2005 US$) of 1961 in Congo (Republic) to that in India?
Your answer should be very brief. 0.01. What is the ratio of the Value added (constant 2005 US$) of 1962 in Congo (Republic) to that in India?
Give a very brief answer. 0.01. What is the ratio of the Value added (constant 2005 US$) in 1963 in Congo (Republic) to that in India?
Provide a succinct answer. 0.01. What is the ratio of the Value added (constant 2005 US$) of 1960 in Costa Rica to that in Guatemala?
Provide a short and direct response. 0.57. What is the ratio of the Value added (constant 2005 US$) of 1961 in Costa Rica to that in Guatemala?
Give a very brief answer. 0.53. What is the ratio of the Value added (constant 2005 US$) in 1962 in Costa Rica to that in Guatemala?
Your answer should be compact. 0.56. What is the ratio of the Value added (constant 2005 US$) in 1963 in Costa Rica to that in Guatemala?
Offer a terse response. 0.55. What is the ratio of the Value added (constant 2005 US$) in 1960 in Costa Rica to that in Honduras?
Offer a very short reply. 2.21. What is the ratio of the Value added (constant 2005 US$) of 1961 in Costa Rica to that in Honduras?
Provide a short and direct response. 2.12. What is the ratio of the Value added (constant 2005 US$) in 1962 in Costa Rica to that in Honduras?
Your answer should be very brief. 2.22. What is the ratio of the Value added (constant 2005 US$) of 1963 in Costa Rica to that in Honduras?
Give a very brief answer. 2.23. What is the ratio of the Value added (constant 2005 US$) of 1960 in Costa Rica to that in India?
Make the answer very short. 0.05. What is the ratio of the Value added (constant 2005 US$) of 1961 in Costa Rica to that in India?
Your response must be concise. 0.05. What is the ratio of the Value added (constant 2005 US$) in 1962 in Costa Rica to that in India?
Your response must be concise. 0.05. What is the ratio of the Value added (constant 2005 US$) of 1963 in Costa Rica to that in India?
Your response must be concise. 0.05. What is the ratio of the Value added (constant 2005 US$) of 1960 in Guatemala to that in Honduras?
Offer a very short reply. 3.87. What is the ratio of the Value added (constant 2005 US$) in 1961 in Guatemala to that in Honduras?
Provide a succinct answer. 3.98. What is the ratio of the Value added (constant 2005 US$) in 1962 in Guatemala to that in Honduras?
Your response must be concise. 3.98. What is the ratio of the Value added (constant 2005 US$) in 1963 in Guatemala to that in Honduras?
Provide a succinct answer. 4.07. What is the ratio of the Value added (constant 2005 US$) of 1960 in Guatemala to that in India?
Provide a short and direct response. 0.09. What is the ratio of the Value added (constant 2005 US$) of 1961 in Guatemala to that in India?
Offer a terse response. 0.09. What is the ratio of the Value added (constant 2005 US$) in 1962 in Guatemala to that in India?
Ensure brevity in your answer.  0.09. What is the ratio of the Value added (constant 2005 US$) of 1963 in Guatemala to that in India?
Provide a short and direct response. 0.09. What is the ratio of the Value added (constant 2005 US$) in 1960 in Honduras to that in India?
Give a very brief answer. 0.02. What is the ratio of the Value added (constant 2005 US$) of 1961 in Honduras to that in India?
Keep it short and to the point. 0.02. What is the ratio of the Value added (constant 2005 US$) of 1962 in Honduras to that in India?
Provide a succinct answer. 0.02. What is the ratio of the Value added (constant 2005 US$) of 1963 in Honduras to that in India?
Provide a succinct answer. 0.02. What is the difference between the highest and the second highest Value added (constant 2005 US$) in 1960?
Give a very brief answer. 1.95e+09. What is the difference between the highest and the second highest Value added (constant 2005 US$) of 1961?
Offer a terse response. 8.08e+09. What is the difference between the highest and the second highest Value added (constant 2005 US$) of 1962?
Your answer should be very brief. 1.19e+1. What is the difference between the highest and the second highest Value added (constant 2005 US$) in 1963?
Your answer should be compact. 1.28e+1. What is the difference between the highest and the lowest Value added (constant 2005 US$) of 1960?
Make the answer very short. 3.24e+1. What is the difference between the highest and the lowest Value added (constant 2005 US$) of 1961?
Your answer should be compact. 3.21e+1. What is the difference between the highest and the lowest Value added (constant 2005 US$) of 1962?
Your answer should be very brief. 3.36e+1. What is the difference between the highest and the lowest Value added (constant 2005 US$) of 1963?
Offer a very short reply. 3.55e+1. 